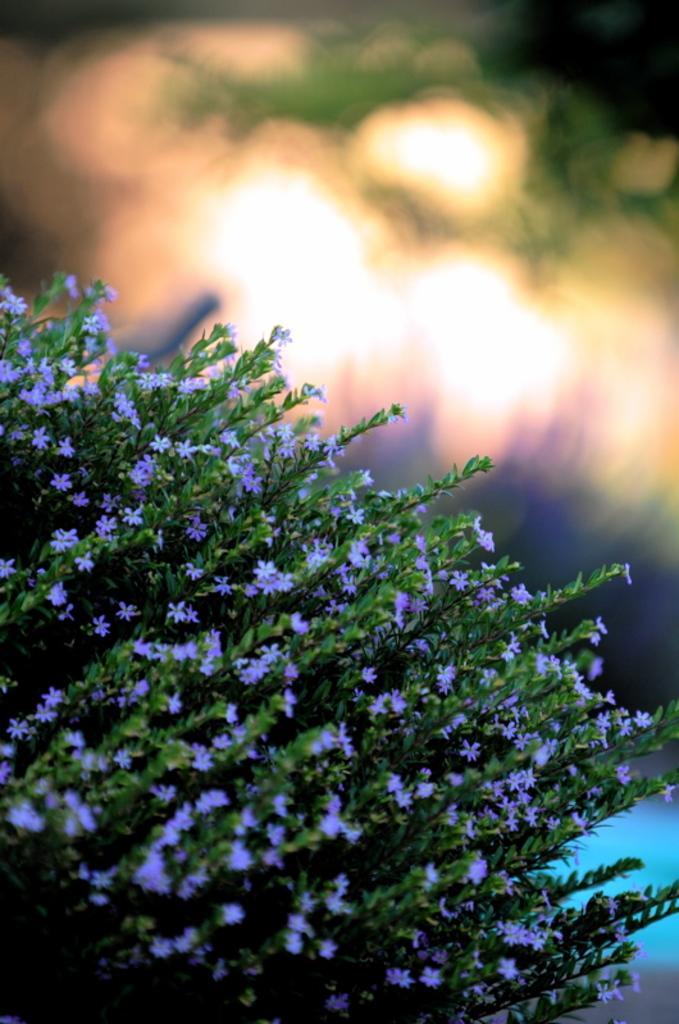Can you describe this image briefly? In the picture there are a bunch of flowering plants and the background of those plants is blur. 